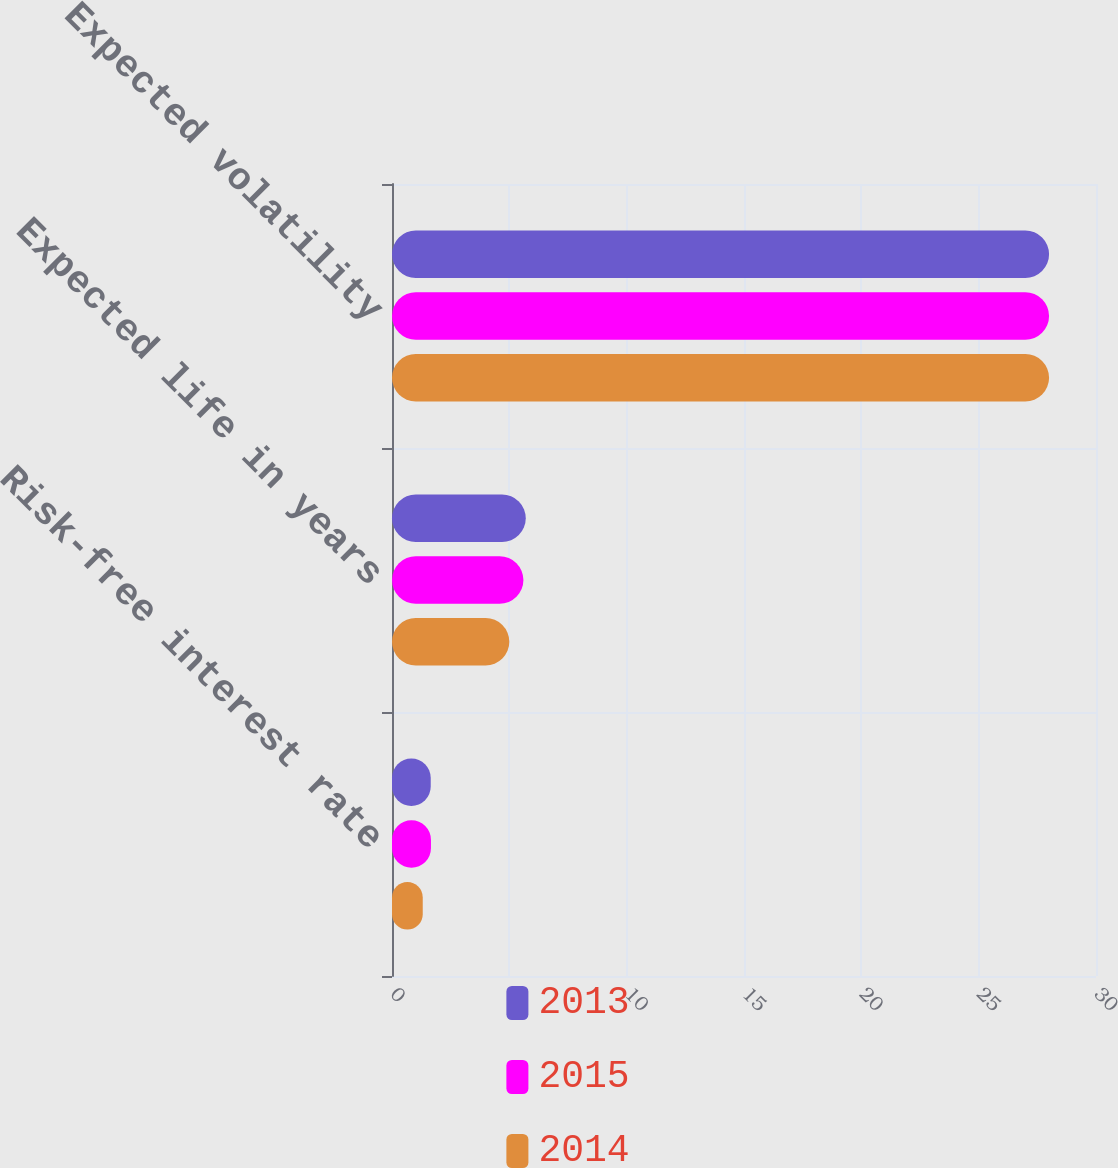Convert chart to OTSL. <chart><loc_0><loc_0><loc_500><loc_500><stacked_bar_chart><ecel><fcel>Risk-free interest rate<fcel>Expected life in years<fcel>Expected volatility<nl><fcel>2013<fcel>1.65<fcel>5.7<fcel>28<nl><fcel>2015<fcel>1.66<fcel>5.6<fcel>28<nl><fcel>2014<fcel>1.31<fcel>5<fcel>28<nl></chart> 